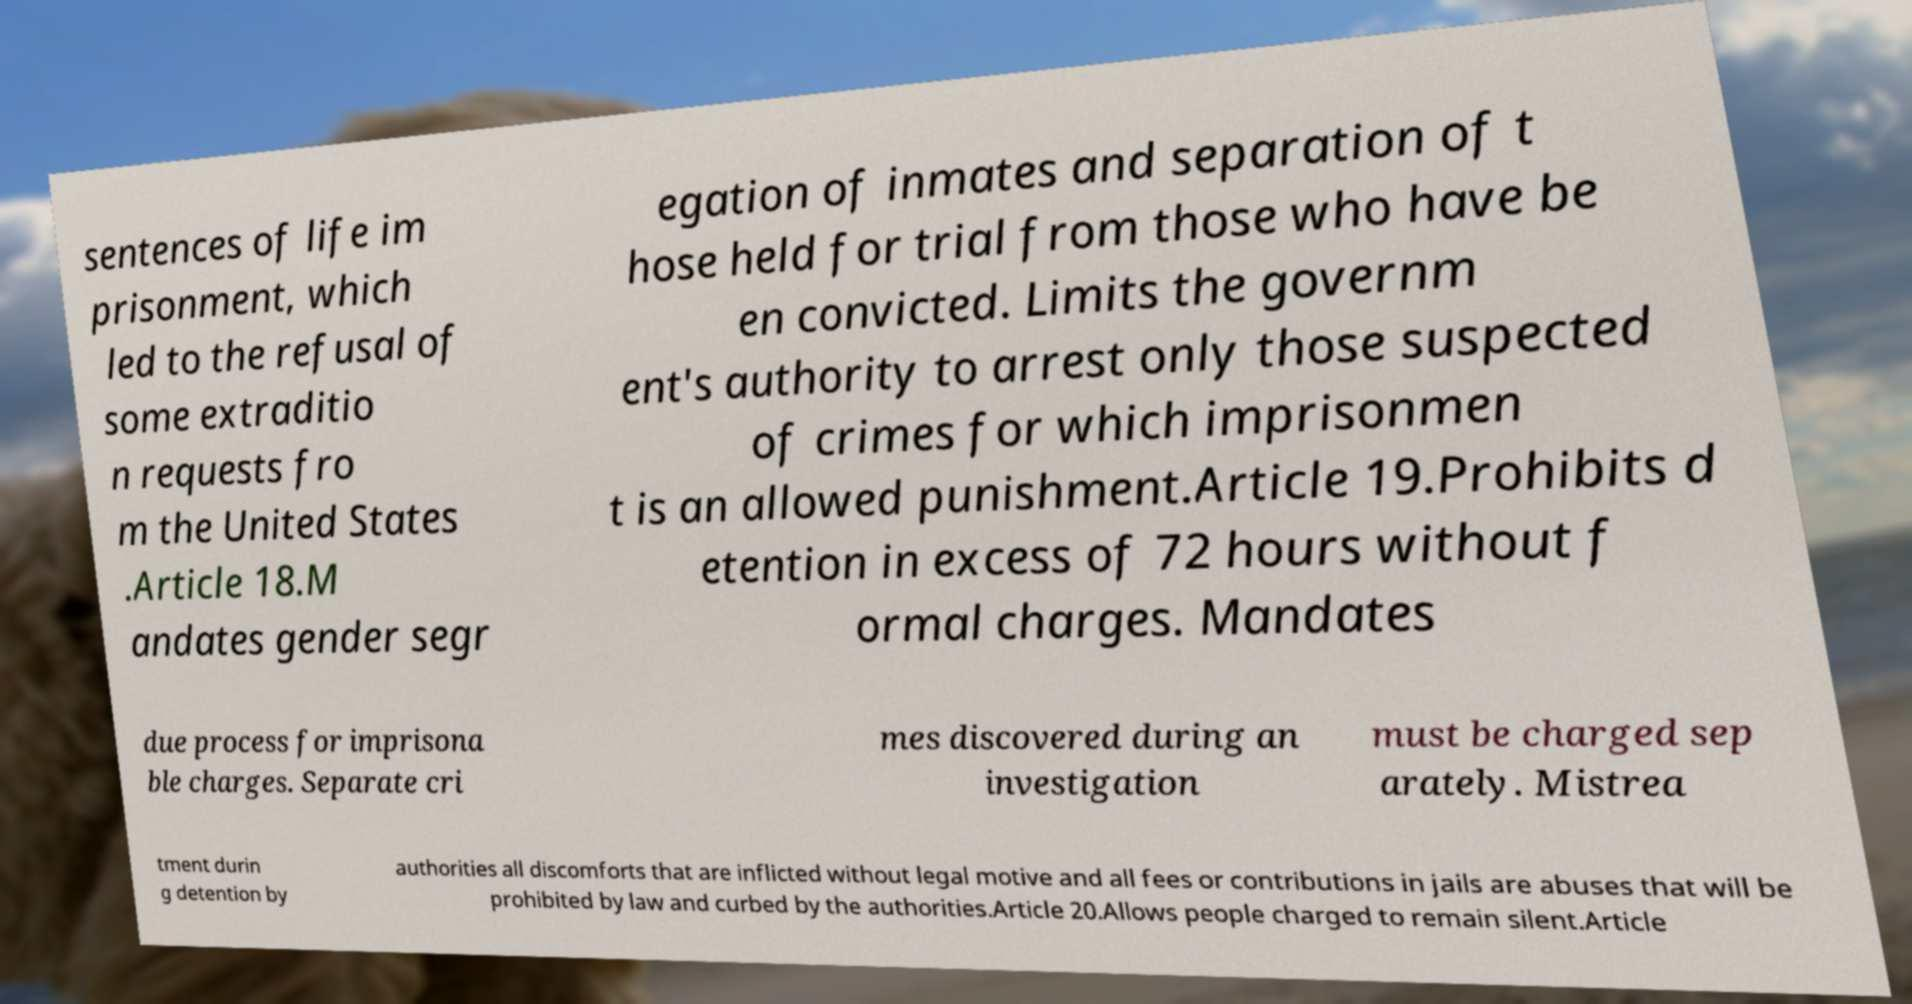There's text embedded in this image that I need extracted. Can you transcribe it verbatim? sentences of life im prisonment, which led to the refusal of some extraditio n requests fro m the United States .Article 18.M andates gender segr egation of inmates and separation of t hose held for trial from those who have be en convicted. Limits the governm ent's authority to arrest only those suspected of crimes for which imprisonmen t is an allowed punishment.Article 19.Prohibits d etention in excess of 72 hours without f ormal charges. Mandates due process for imprisona ble charges. Separate cri mes discovered during an investigation must be charged sep arately. Mistrea tment durin g detention by authorities all discomforts that are inflicted without legal motive and all fees or contributions in jails are abuses that will be prohibited by law and curbed by the authorities.Article 20.Allows people charged to remain silent.Article 